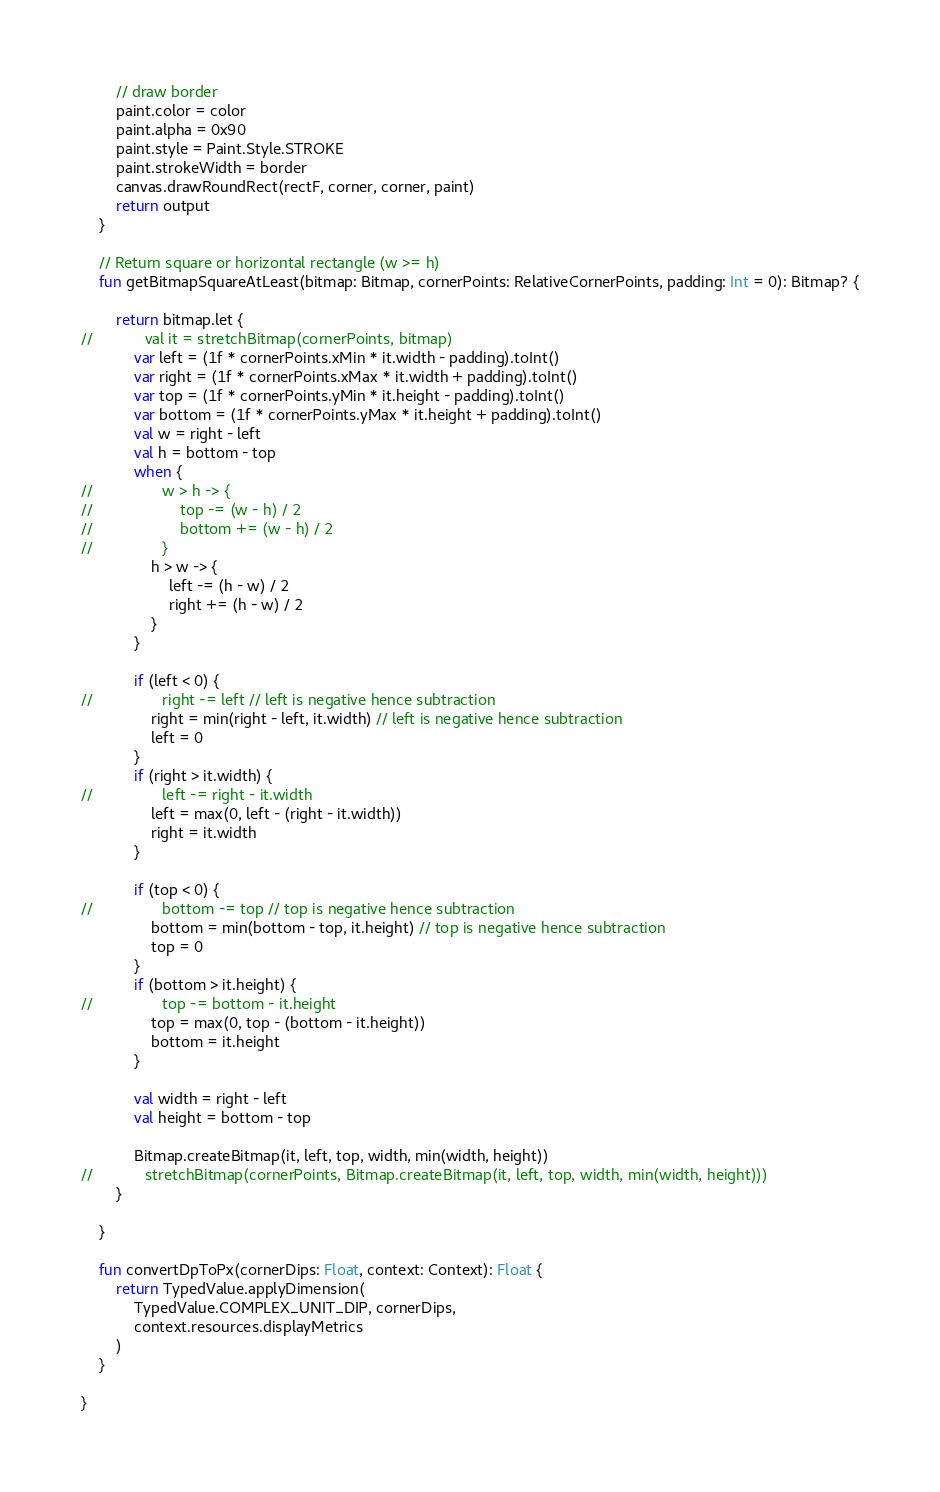<code> <loc_0><loc_0><loc_500><loc_500><_Kotlin_>        // draw border
        paint.color = color
        paint.alpha = 0x90
        paint.style = Paint.Style.STROKE
        paint.strokeWidth = border
        canvas.drawRoundRect(rectF, corner, corner, paint)
        return output
    }

    // Return square or horizontal rectangle (w >= h)
    fun getBitmapSquareAtLeast(bitmap: Bitmap, cornerPoints: RelativeCornerPoints, padding: Int = 0): Bitmap? {

        return bitmap.let {
//            val it = stretchBitmap(cornerPoints, bitmap)
            var left = (1f * cornerPoints.xMin * it.width - padding).toInt()
            var right = (1f * cornerPoints.xMax * it.width + padding).toInt()
            var top = (1f * cornerPoints.yMin * it.height - padding).toInt()
            var bottom = (1f * cornerPoints.yMax * it.height + padding).toInt()
            val w = right - left
            val h = bottom - top
            when {
//                w > h -> {
//                    top -= (w - h) / 2
//                    bottom += (w - h) / 2
//                }
                h > w -> {
                    left -= (h - w) / 2
                    right += (h - w) / 2
                }
            }

            if (left < 0) {
//                right -= left // left is negative hence subtraction
                right = min(right - left, it.width) // left is negative hence subtraction
                left = 0
            }
            if (right > it.width) {
//                left -= right - it.width
                left = max(0, left - (right - it.width))
                right = it.width
            }

            if (top < 0) {
//                bottom -= top // top is negative hence subtraction
                bottom = min(bottom - top, it.height) // top is negative hence subtraction
                top = 0
            }
            if (bottom > it.height) {
//                top -= bottom - it.height
                top = max(0, top - (bottom - it.height))
                bottom = it.height
            }

            val width = right - left
            val height = bottom - top

            Bitmap.createBitmap(it, left, top, width, min(width, height))
//            stretchBitmap(cornerPoints, Bitmap.createBitmap(it, left, top, width, min(width, height)))
        }

    }

    fun convertDpToPx(cornerDips: Float, context: Context): Float {
        return TypedValue.applyDimension(
            TypedValue.COMPLEX_UNIT_DIP, cornerDips,
            context.resources.displayMetrics
        )
    }

}</code> 